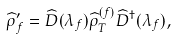<formula> <loc_0><loc_0><loc_500><loc_500>\widehat { \rho } _ { f } ^ { \prime } = \widehat { D } ( \lambda _ { f } ) \widehat { \rho } _ { T } ^ { ( f ) } \widehat { D } ^ { \dagger } ( \lambda _ { f } ) ,</formula> 